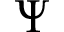Convert formula to latex. <formula><loc_0><loc_0><loc_500><loc_500>\Psi</formula> 